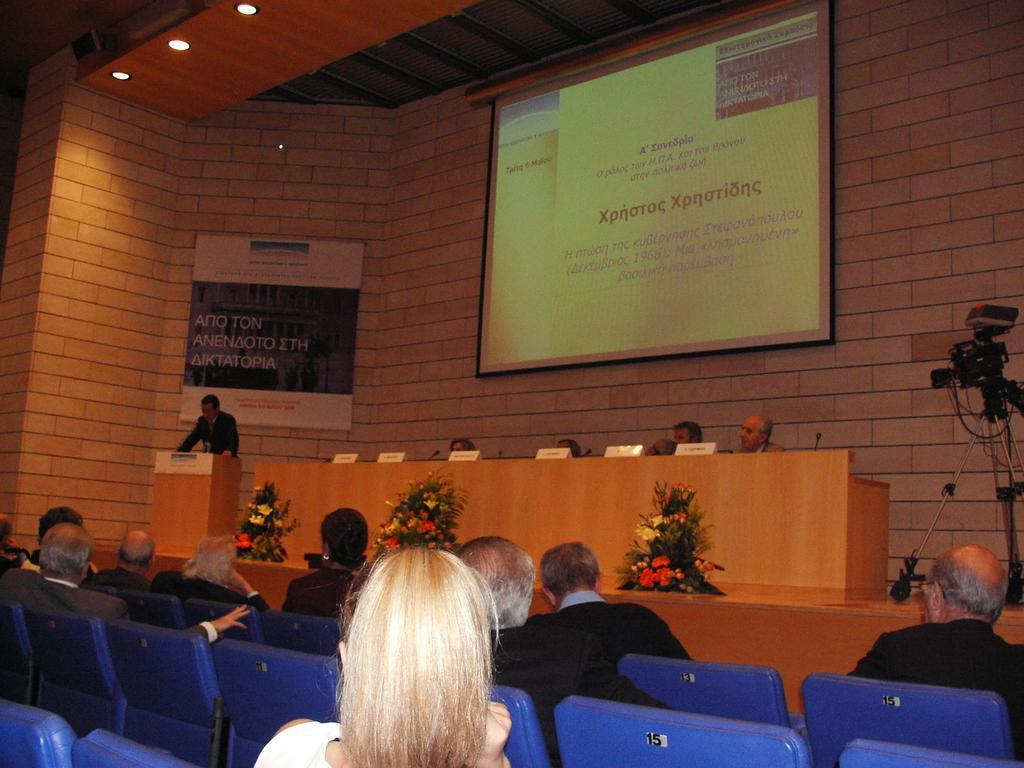Could you give a brief overview of what you see in this image? In this image there is a person standing in front of the table there is a mic, beside the table there is another table with name plates, mics and a few other objects and few people are sitting on their chairs, in front of the table there are few bouquets and a camera with a stand on the stage, behind them there is a banner with some text and a screen hanging on the wall, at the top of the image there is a ceiling. At the bottom of the image there are a few people sitting on their chairs. 